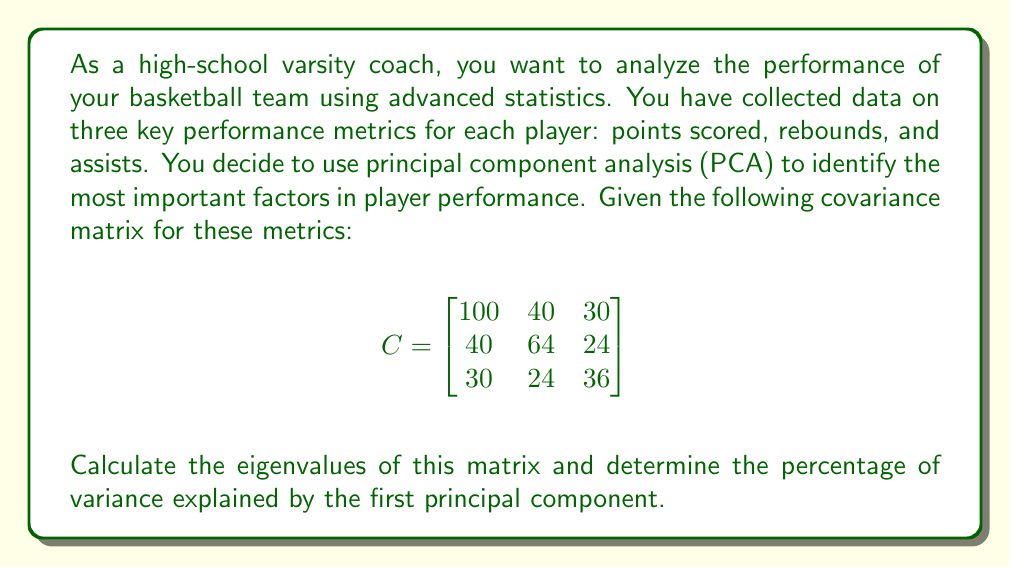Show me your answer to this math problem. To solve this problem, we'll follow these steps:

1) Find the characteristic equation of the covariance matrix.
2) Solve the characteristic equation to find the eigenvalues.
3) Calculate the total variance.
4) Determine the percentage of variance explained by the largest eigenvalue.

Step 1: Find the characteristic equation

The characteristic equation is given by $\det(C - \lambda I) = 0$, where $I$ is the 3x3 identity matrix.

$$
\det\begin{pmatrix}
100-\lambda & 40 & 30 \\
40 & 64-\lambda & 24 \\
30 & 24 & 36-\lambda
\end{pmatrix} = 0
$$

Step 2: Solve the characteristic equation

Expanding the determinant:

$$(100-\lambda)(64-\lambda)(36-\lambda) - 40^2(36-\lambda) - 30^2(64-\lambda) - 24^2(100-\lambda) + 2(40)(30)(24) = 0$$

This simplifies to:

$$-\lambda^3 + 200\lambda^2 - 11304\lambda + 172800 = 0$$

Using a computer algebra system or calculator, we find the roots of this equation:

$\lambda_1 \approx 156.45$
$\lambda_2 \approx 35.28$
$\lambda_3 \approx 8.27$

Step 3: Calculate the total variance

The total variance is the sum of the eigenvalues:

$$\text{Total Variance} = 156.45 + 35.28 + 8.27 = 200$$

Step 4: Determine the percentage of variance explained by the first principal component

The first principal component corresponds to the largest eigenvalue, $\lambda_1 = 156.45$.

Percentage of variance explained = $\frac{\lambda_1}{\text{Total Variance}} \times 100\%$

$= \frac{156.45}{200} \times 100\% \approx 78.23\%$
Answer: 78.23% 